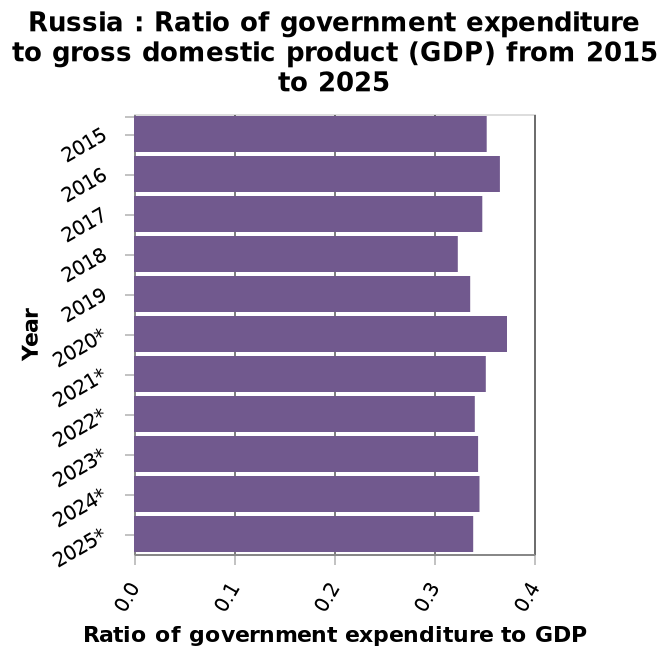<image>
What does the y-axis measure?  The y-axis measures "Year" using a categorical scale with 2015 on one end and 2025 on the other. Offer a thorough analysis of the image. The ratio during this period ranges from just over 0,3 to under 0,4. The highest ratio was in 2020, while the lowest was in 2018. The trend fluctuates before it peaks at 2020 and then decreases. What does the x-axis plot?  The x-axis plots the "Ratio of government expenditure to GDP" with a linear scale ranging from 0.0 to 0.4. Describe the trend of the ratio during this period. The trend fluctuates before peaking in 2020 and then decreases. What does the y-axis represent in the bar graph?  The y-axis represents the years from 2015 to 2025. please enumerates aspects of the construction of the chart This bar chart is named Russia : Ratio of government expenditure to gross domestic product (GDP) from 2015 to 2025. The y-axis measures Year using a categorical scale with 2015 on one end and  at the other. The x-axis plots Ratio of government expenditure to GDP with a linear scale from 0.0 to 0.4. When was the lowest ratio observed? The lowest ratio was observed in 2018. What happens to the trend after peaking in 2020? The trend decreases after peaking in 2020. In which year was the highest ratio recorded? The highest ratio was recorded in 2020. 